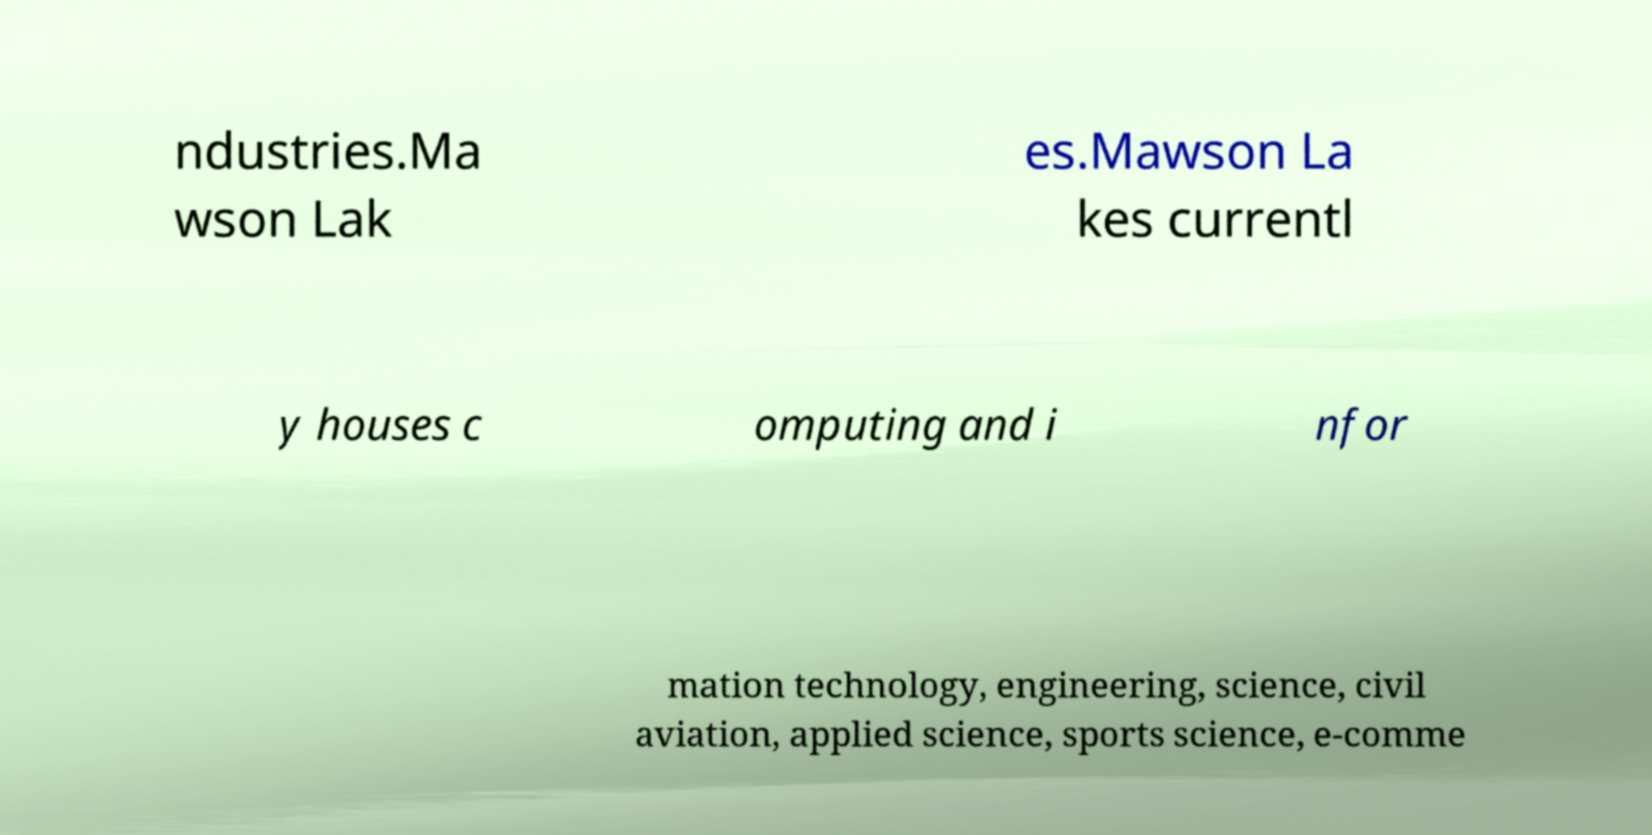Please identify and transcribe the text found in this image. ndustries.Ma wson Lak es.Mawson La kes currentl y houses c omputing and i nfor mation technology, engineering, science, civil aviation, applied science, sports science, e-comme 